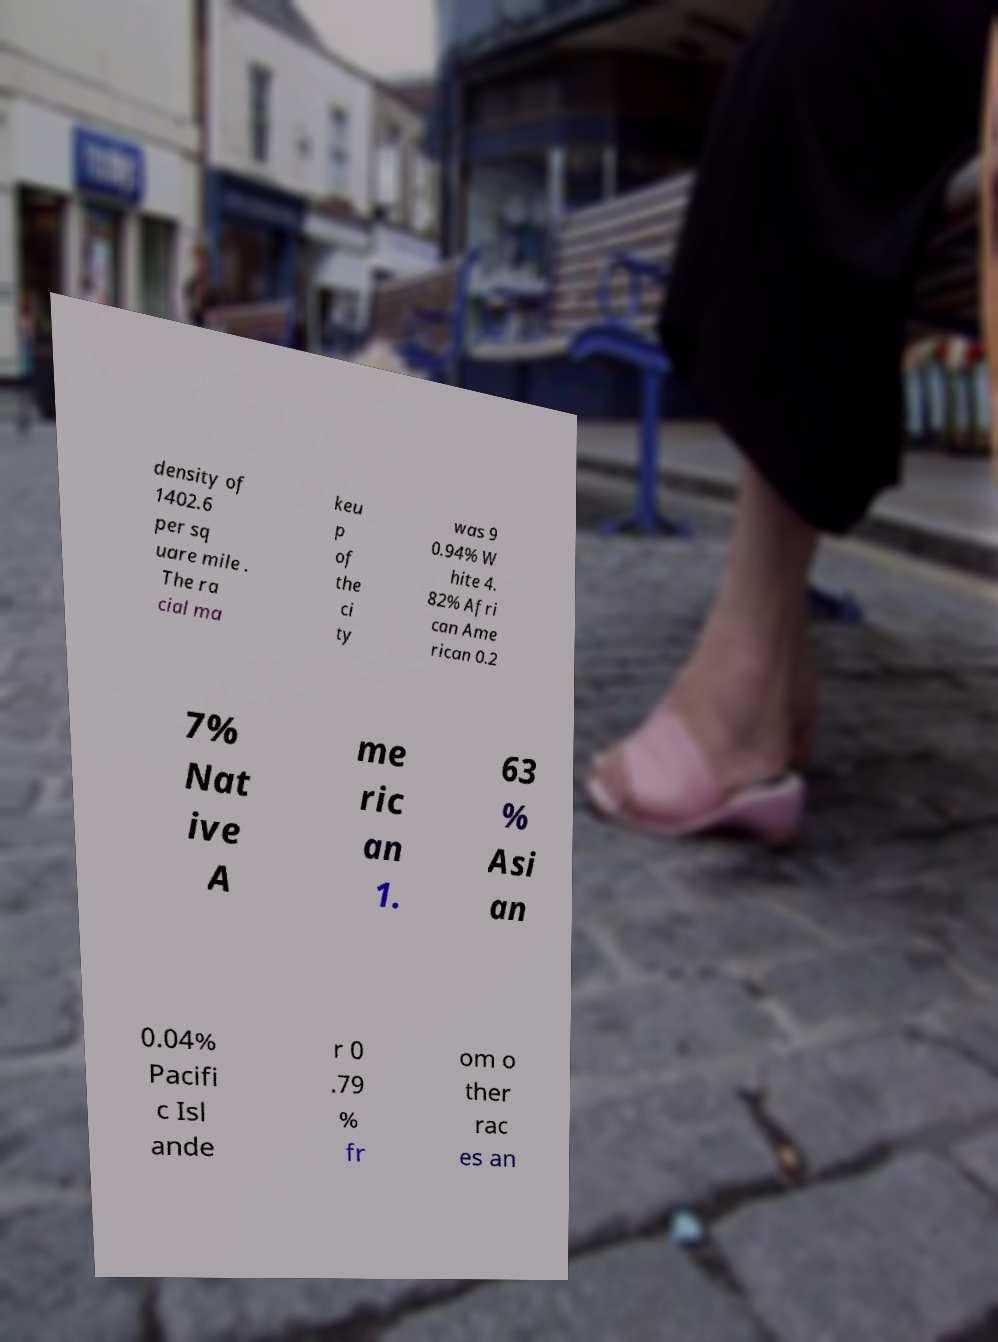What messages or text are displayed in this image? I need them in a readable, typed format. density of 1402.6 per sq uare mile . The ra cial ma keu p of the ci ty was 9 0.94% W hite 4. 82% Afri can Ame rican 0.2 7% Nat ive A me ric an 1. 63 % Asi an 0.04% Pacifi c Isl ande r 0 .79 % fr om o ther rac es an 